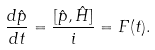<formula> <loc_0><loc_0><loc_500><loc_500>\frac { d \hat { p } } { d t } = \frac { [ \hat { p } , \hat { H } ] } { i } = F ( t ) .</formula> 